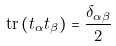<formula> <loc_0><loc_0><loc_500><loc_500>\mathrm { t r } \left ( t _ { \alpha } t _ { \beta } \right ) = \frac { \delta _ { \alpha \beta } } { 2 }</formula> 